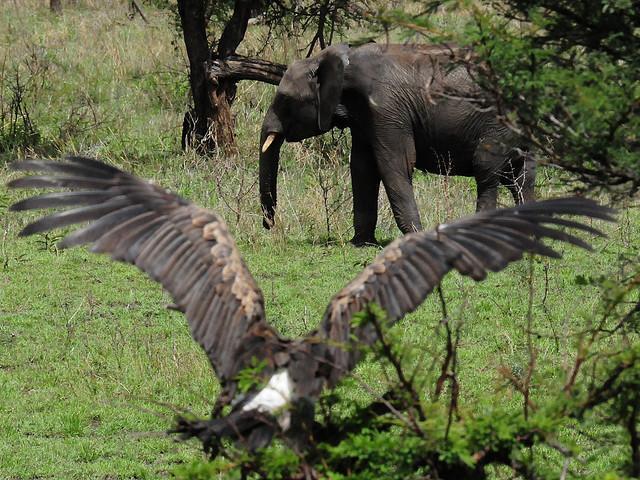Is this affirmation: "The bird is toward the elephant." correct?
Answer yes or no. Yes. Does the image validate the caption "The bird is facing the elephant."?
Answer yes or no. Yes. Does the caption "The bird is touching the elephant." correctly depict the image?
Answer yes or no. No. 